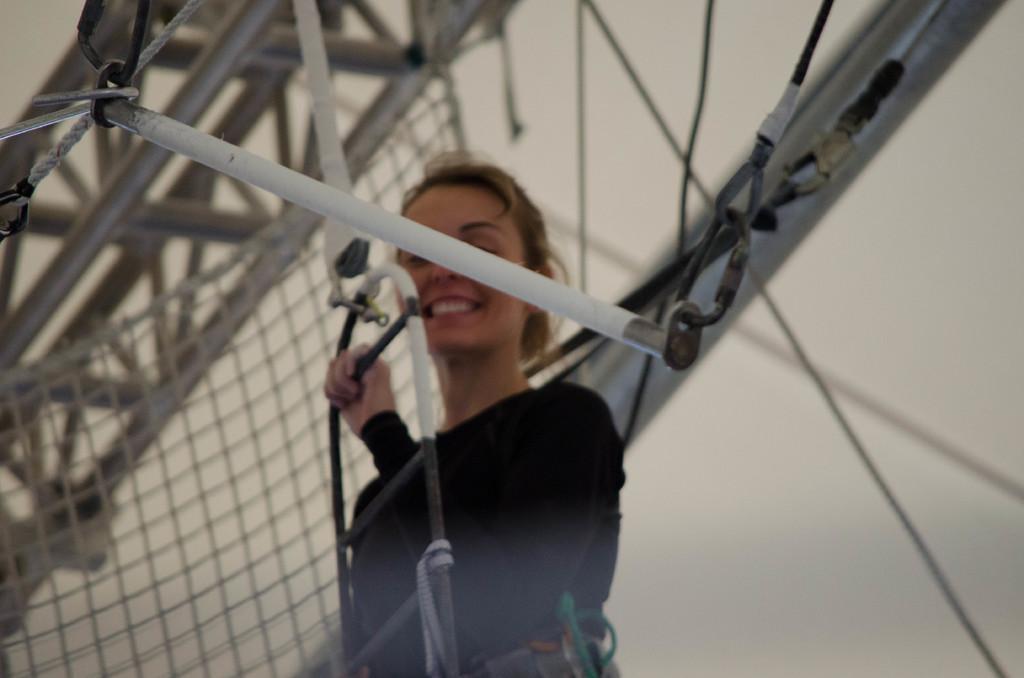Can you describe this image briefly? In this image we can see a person standing and holding an object. And there are rods and net. In the background it looks like a wall. 